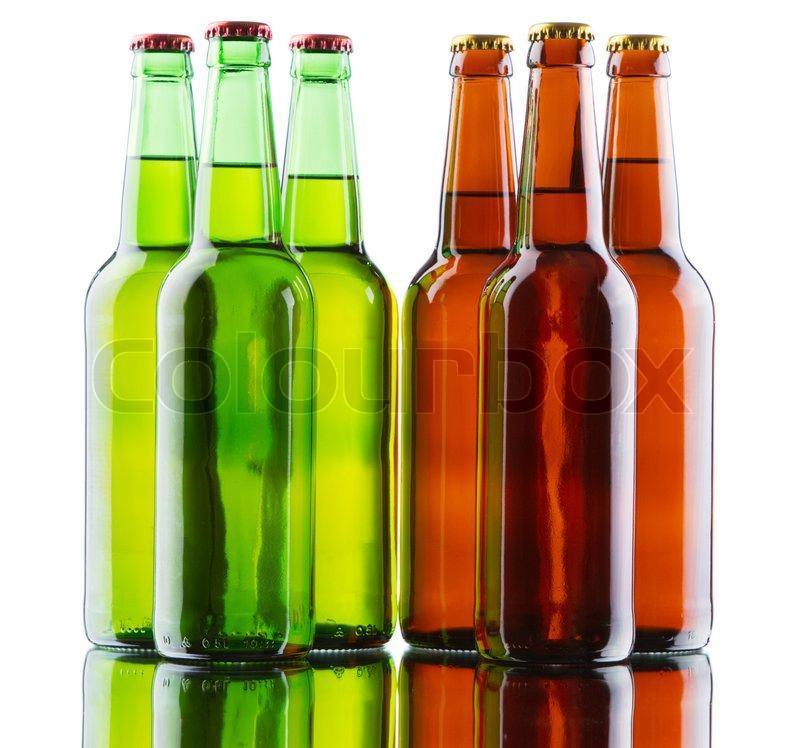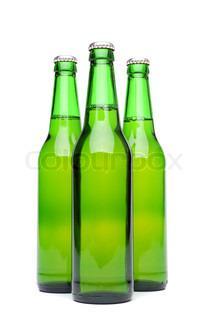The first image is the image on the left, the second image is the image on the right. Given the left and right images, does the statement "There are no more than six glass bottles" hold true? Answer yes or no. No. 